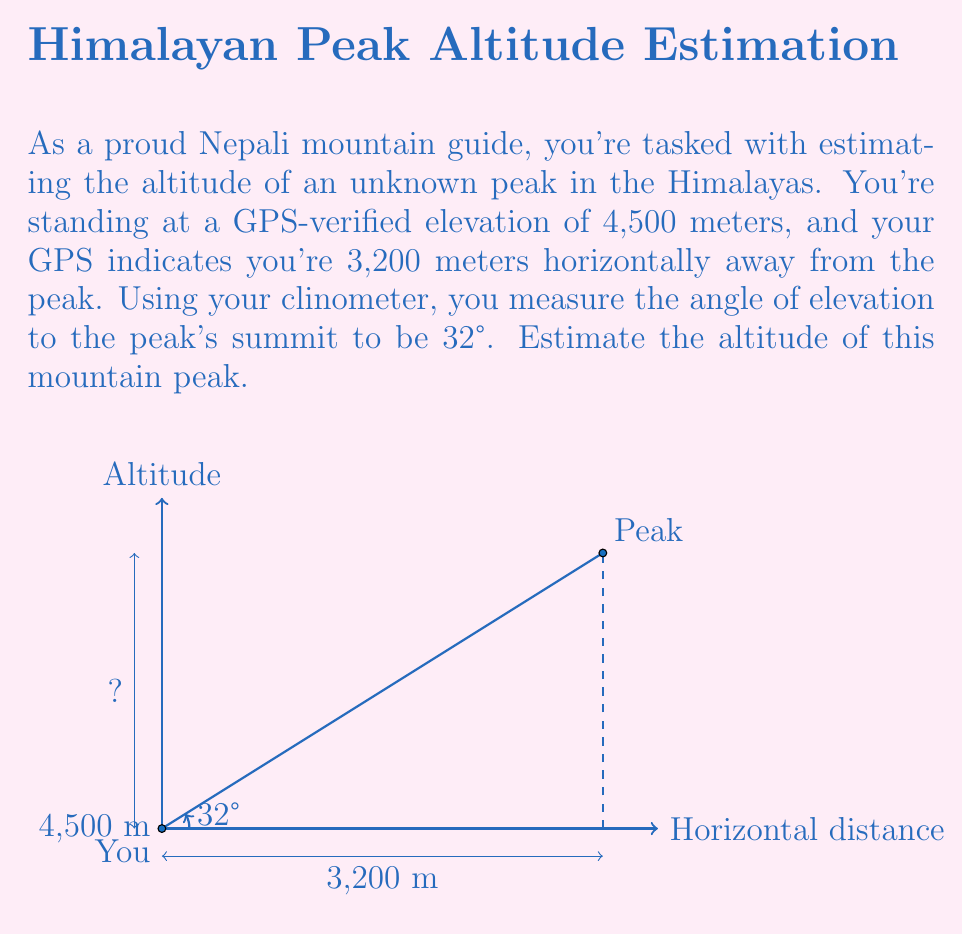Solve this math problem. Let's approach this step-by-step using trigonometry:

1) First, let's define our variables:
   - Base elevation (your position): $b = 4500$ meters
   - Horizontal distance: $d = 3200$ meters
   - Angle of elevation: $\theta = 32°$

2) We need to find the height (h) of the triangle formed by your position, the peak, and the horizontal line. This height plus your base elevation will give us the peak's altitude.

3) We can use the tangent function to relate the angle and the sides of the right triangle:

   $$\tan(\theta) = \frac{h}{d}$$

4) Rearranging this equation to solve for h:

   $$h = d \cdot \tan(\theta)$$

5) Plugging in our values:

   $$h = 3200 \cdot \tan(32°)$$

6) Using a calculator (or trigonometric tables):

   $$h \approx 3200 \cdot 0.6249 \approx 1999.68 \text{ meters}$$

7) Now, to get the peak's altitude, we add this height to our base elevation:

   $$\text{Peak Altitude} = b + h = 4500 + 1999.68 \approx 6499.68 \text{ meters}$$

8) Rounding to the nearest meter (as estimations don't require more precision):

   $$\text{Peak Altitude} \approx 6500 \text{ meters}$$
Answer: 6500 meters 